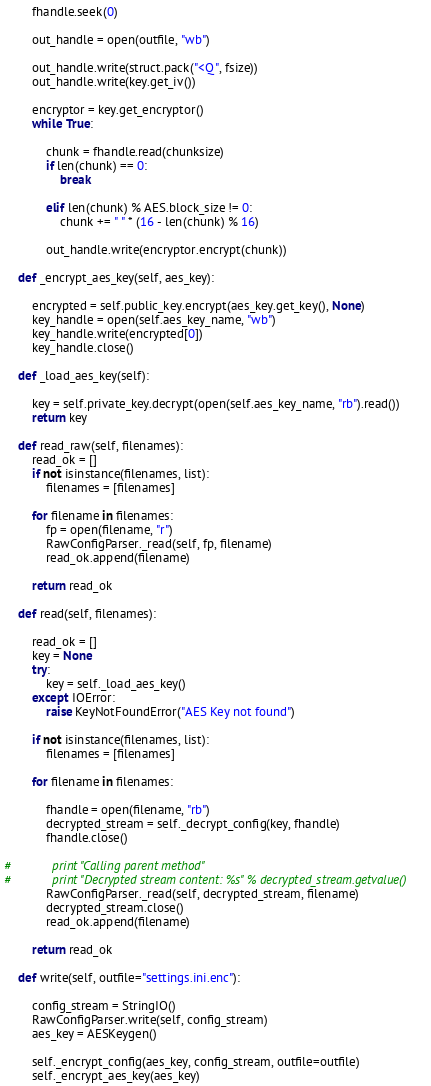Convert code to text. <code><loc_0><loc_0><loc_500><loc_500><_Python_>        fhandle.seek(0)

        out_handle = open(outfile, "wb")

        out_handle.write(struct.pack("<Q", fsize))
        out_handle.write(key.get_iv())

        encryptor = key.get_encryptor()
        while True:

            chunk = fhandle.read(chunksize)
            if len(chunk) == 0:
                break

            elif len(chunk) % AES.block_size != 0:
                chunk += " " * (16 - len(chunk) % 16)

            out_handle.write(encryptor.encrypt(chunk))

    def _encrypt_aes_key(self, aes_key):

        encrypted = self.public_key.encrypt(aes_key.get_key(), None)
        key_handle = open(self.aes_key_name, "wb")
        key_handle.write(encrypted[0])
        key_handle.close()

    def _load_aes_key(self):

        key = self.private_key.decrypt(open(self.aes_key_name, "rb").read())
        return key

    def read_raw(self, filenames):
        read_ok = []
        if not isinstance(filenames, list):
            filenames = [filenames]

        for filename in filenames:
            fp = open(filename, "r")
            RawConfigParser._read(self, fp, filename)
            read_ok.append(filename)

        return read_ok

    def read(self, filenames):

        read_ok = []
        key = None
        try:
            key = self._load_aes_key()
        except IOError:
            raise KeyNotFoundError("AES Key not found")

        if not isinstance(filenames, list):
            filenames = [filenames]

        for filename in filenames:

            fhandle = open(filename, "rb")
            decrypted_stream = self._decrypt_config(key, fhandle)
            fhandle.close()

#            print "Calling parent method"
#            print "Decrypted stream content: %s" % decrypted_stream.getvalue()
            RawConfigParser._read(self, decrypted_stream, filename)
            decrypted_stream.close()
            read_ok.append(filename)

        return read_ok

    def write(self, outfile="settings.ini.enc"):

        config_stream = StringIO()
        RawConfigParser.write(self, config_stream)
        aes_key = AESKeygen()

        self._encrypt_config(aes_key, config_stream, outfile=outfile)
        self._encrypt_aes_key(aes_key)
</code> 